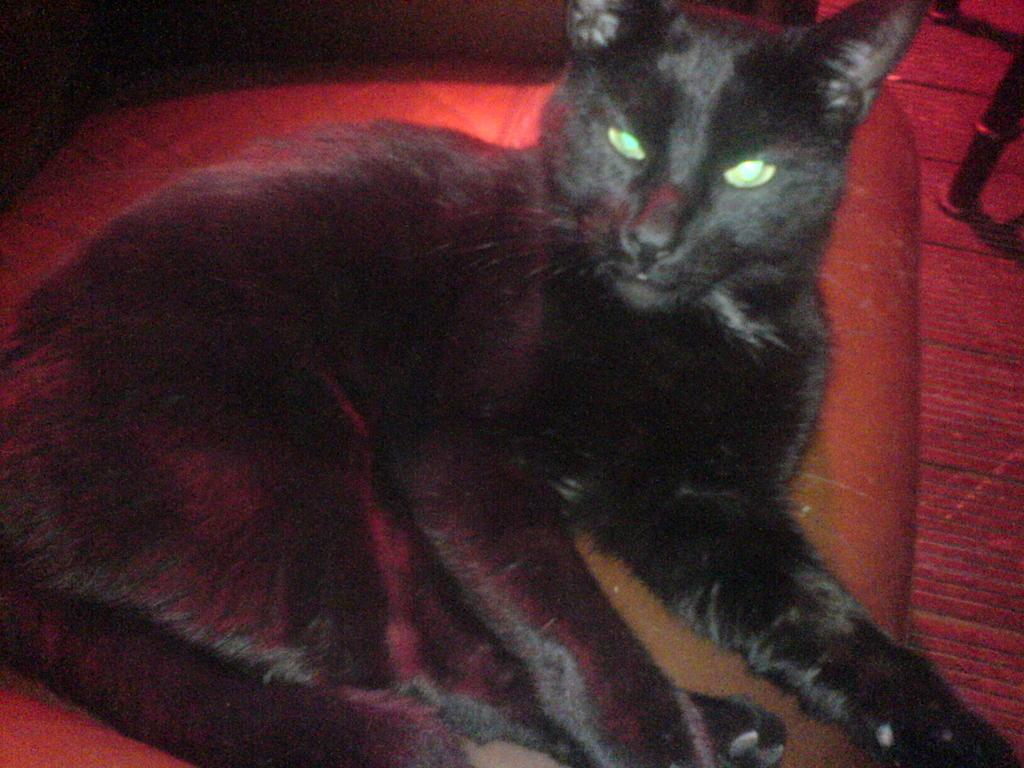What type of animal is in the picture? There is a black cat in the picture. What is the cat doing in the image? The cat is sitting on a chair. What is at the bottom of the image? There is a mat at the bottom of the image. Can you describe the object in the image? Unfortunately, the facts provided do not give any details about the object in the image. What color is the sweater the cat is wearing in the image? The cat is not wearing a sweater in the image. How many turkeys are visible in the image? There are no turkeys present in the image. 